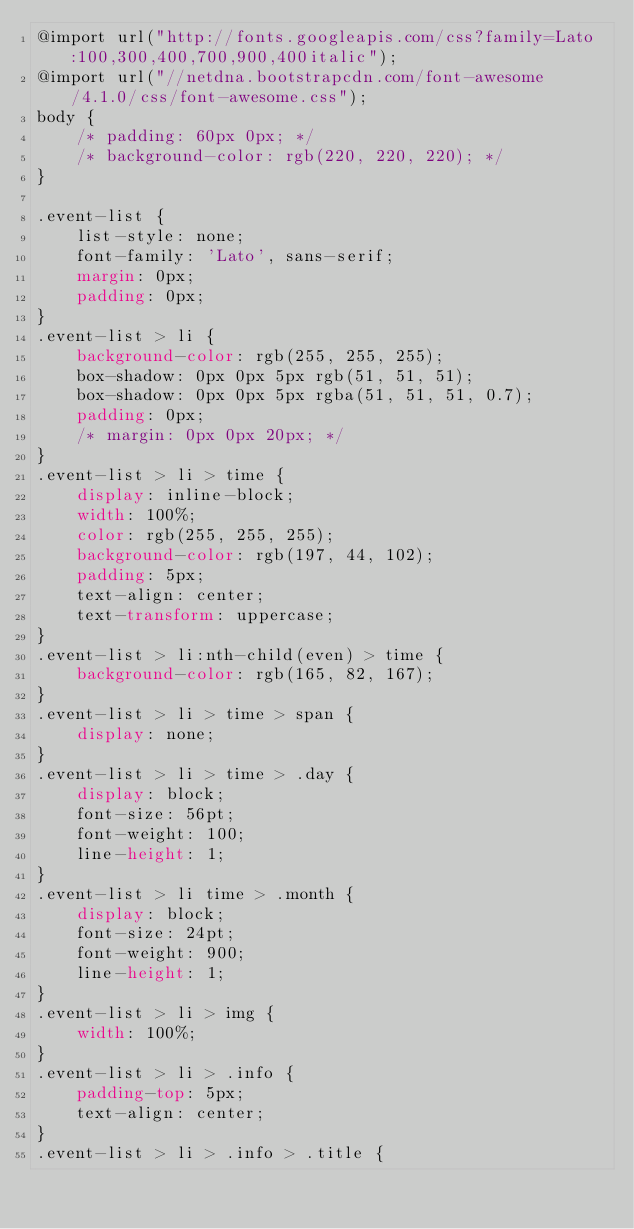Convert code to text. <code><loc_0><loc_0><loc_500><loc_500><_CSS_>@import url("http://fonts.googleapis.com/css?family=Lato:100,300,400,700,900,400italic");
@import url("//netdna.bootstrapcdn.com/font-awesome/4.1.0/css/font-awesome.css");
body {
    /* padding: 60px 0px; */
    /* background-color: rgb(220, 220, 220); */
}

.event-list {
    list-style: none;
    font-family: 'Lato', sans-serif;
    margin: 0px;
    padding: 0px;
}
.event-list > li {
    background-color: rgb(255, 255, 255);
    box-shadow: 0px 0px 5px rgb(51, 51, 51);
    box-shadow: 0px 0px 5px rgba(51, 51, 51, 0.7);
    padding: 0px;
    /* margin: 0px 0px 20px; */
}
.event-list > li > time {
    display: inline-block;
    width: 100%;
    color: rgb(255, 255, 255);
    background-color: rgb(197, 44, 102);
    padding: 5px;
    text-align: center;
    text-transform: uppercase;
}
.event-list > li:nth-child(even) > time {
    background-color: rgb(165, 82, 167);
}
.event-list > li > time > span {
    display: none;
}
.event-list > li > time > .day {
    display: block;
    font-size: 56pt;
    font-weight: 100;
    line-height: 1;
}
.event-list > li time > .month {
    display: block;
    font-size: 24pt;
    font-weight: 900;
    line-height: 1;
}
.event-list > li > img {
    width: 100%;
}
.event-list > li > .info {
    padding-top: 5px;
    text-align: center;
}
.event-list > li > .info > .title {</code> 